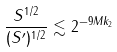Convert formula to latex. <formula><loc_0><loc_0><loc_500><loc_500>\frac { S ^ { 1 / 2 } } { ( S ^ { \prime } ) ^ { 1 / 2 } } \lesssim 2 ^ { - 9 M k _ { 2 } }</formula> 